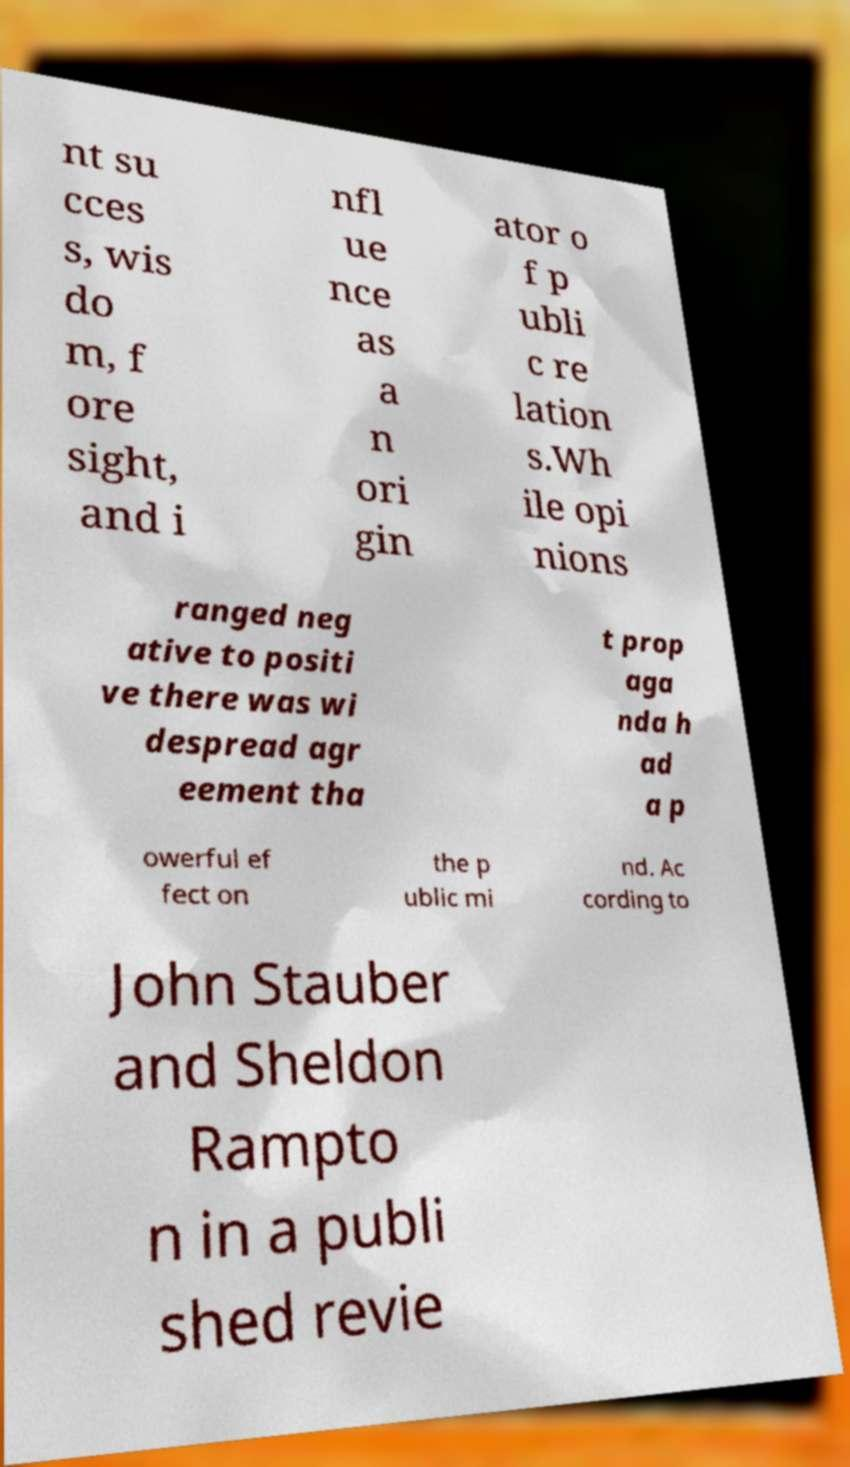Can you read and provide the text displayed in the image?This photo seems to have some interesting text. Can you extract and type it out for me? nt su cces s, wis do m, f ore sight, and i nfl ue nce as a n ori gin ator o f p ubli c re lation s.Wh ile opi nions ranged neg ative to positi ve there was wi despread agr eement tha t prop aga nda h ad a p owerful ef fect on the p ublic mi nd. Ac cording to John Stauber and Sheldon Rampto n in a publi shed revie 